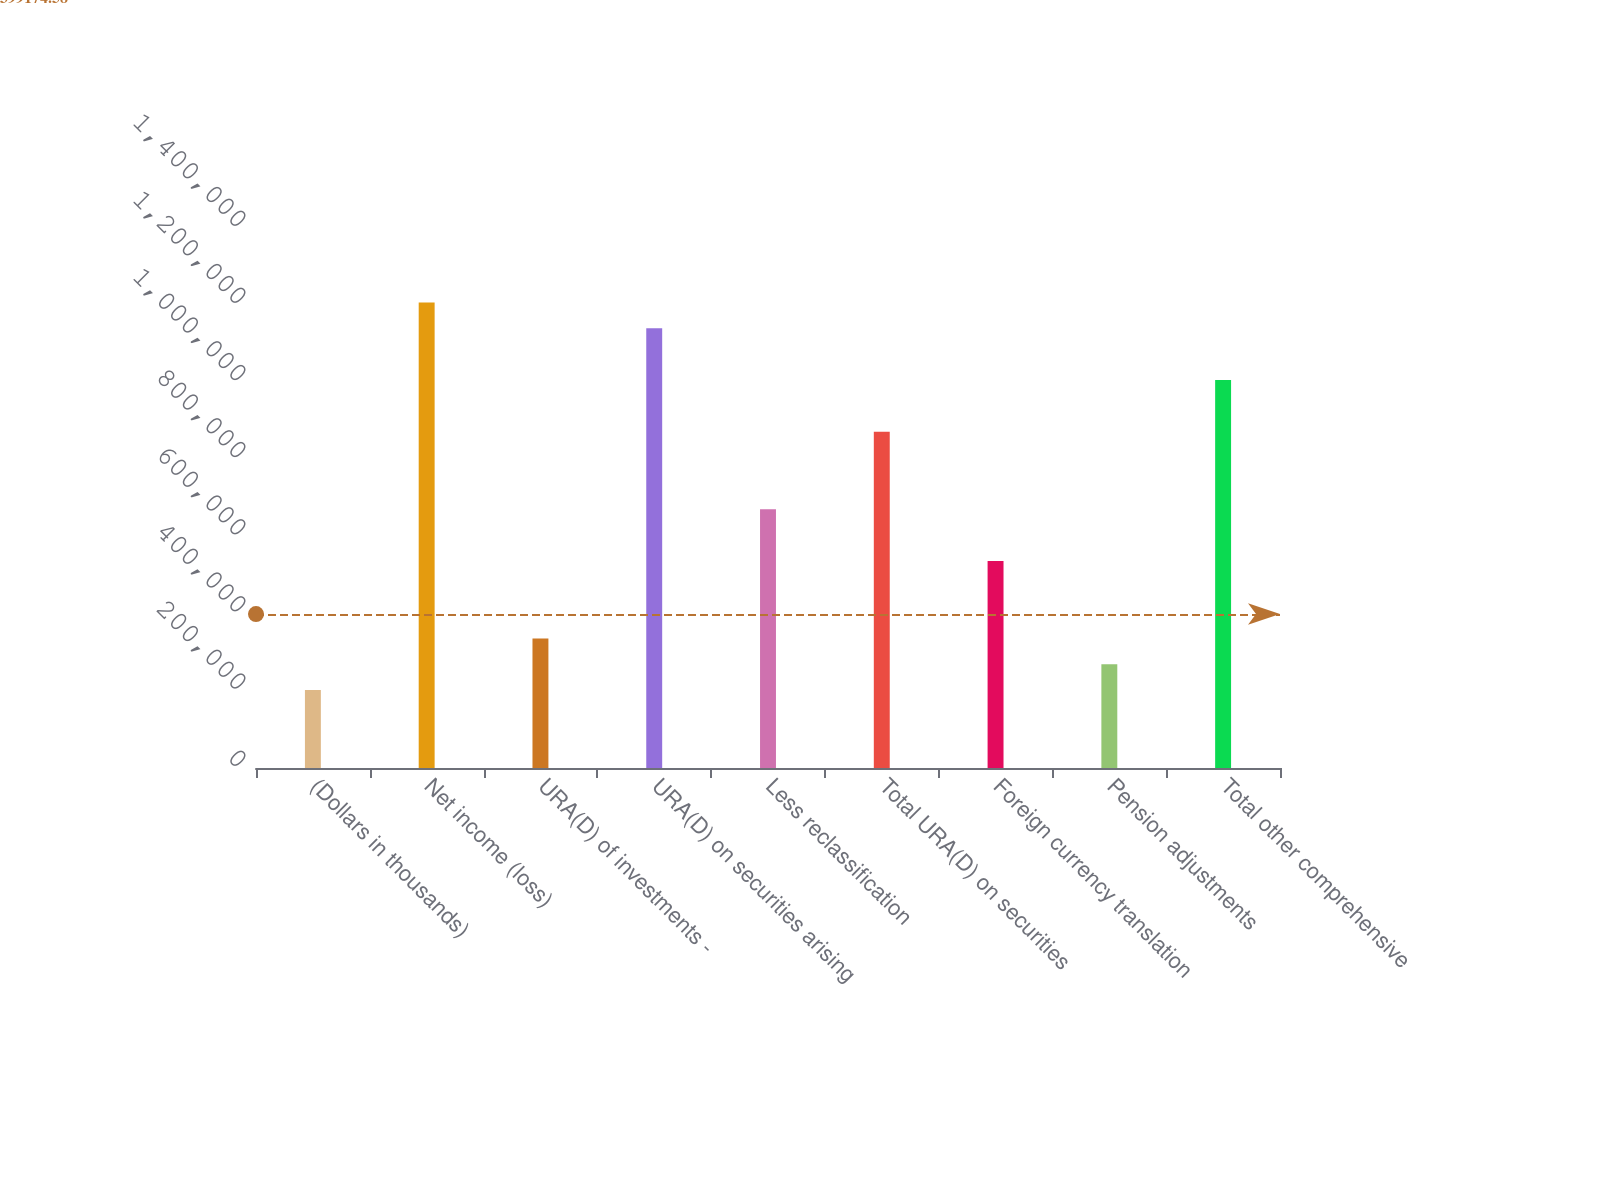<chart> <loc_0><loc_0><loc_500><loc_500><bar_chart><fcel>(Dollars in thousands)<fcel>Net income (loss)<fcel>URA(D) of investments -<fcel>URA(D) on securities arising<fcel>Less reclassification<fcel>Total URA(D) on securities<fcel>Foreign currency translation<fcel>Pension adjustments<fcel>Total other comprehensive<nl><fcel>201976<fcel>1.20697e+06<fcel>335976<fcel>1.13997e+06<fcel>670974<fcel>871973<fcel>536975<fcel>268976<fcel>1.00597e+06<nl></chart> 